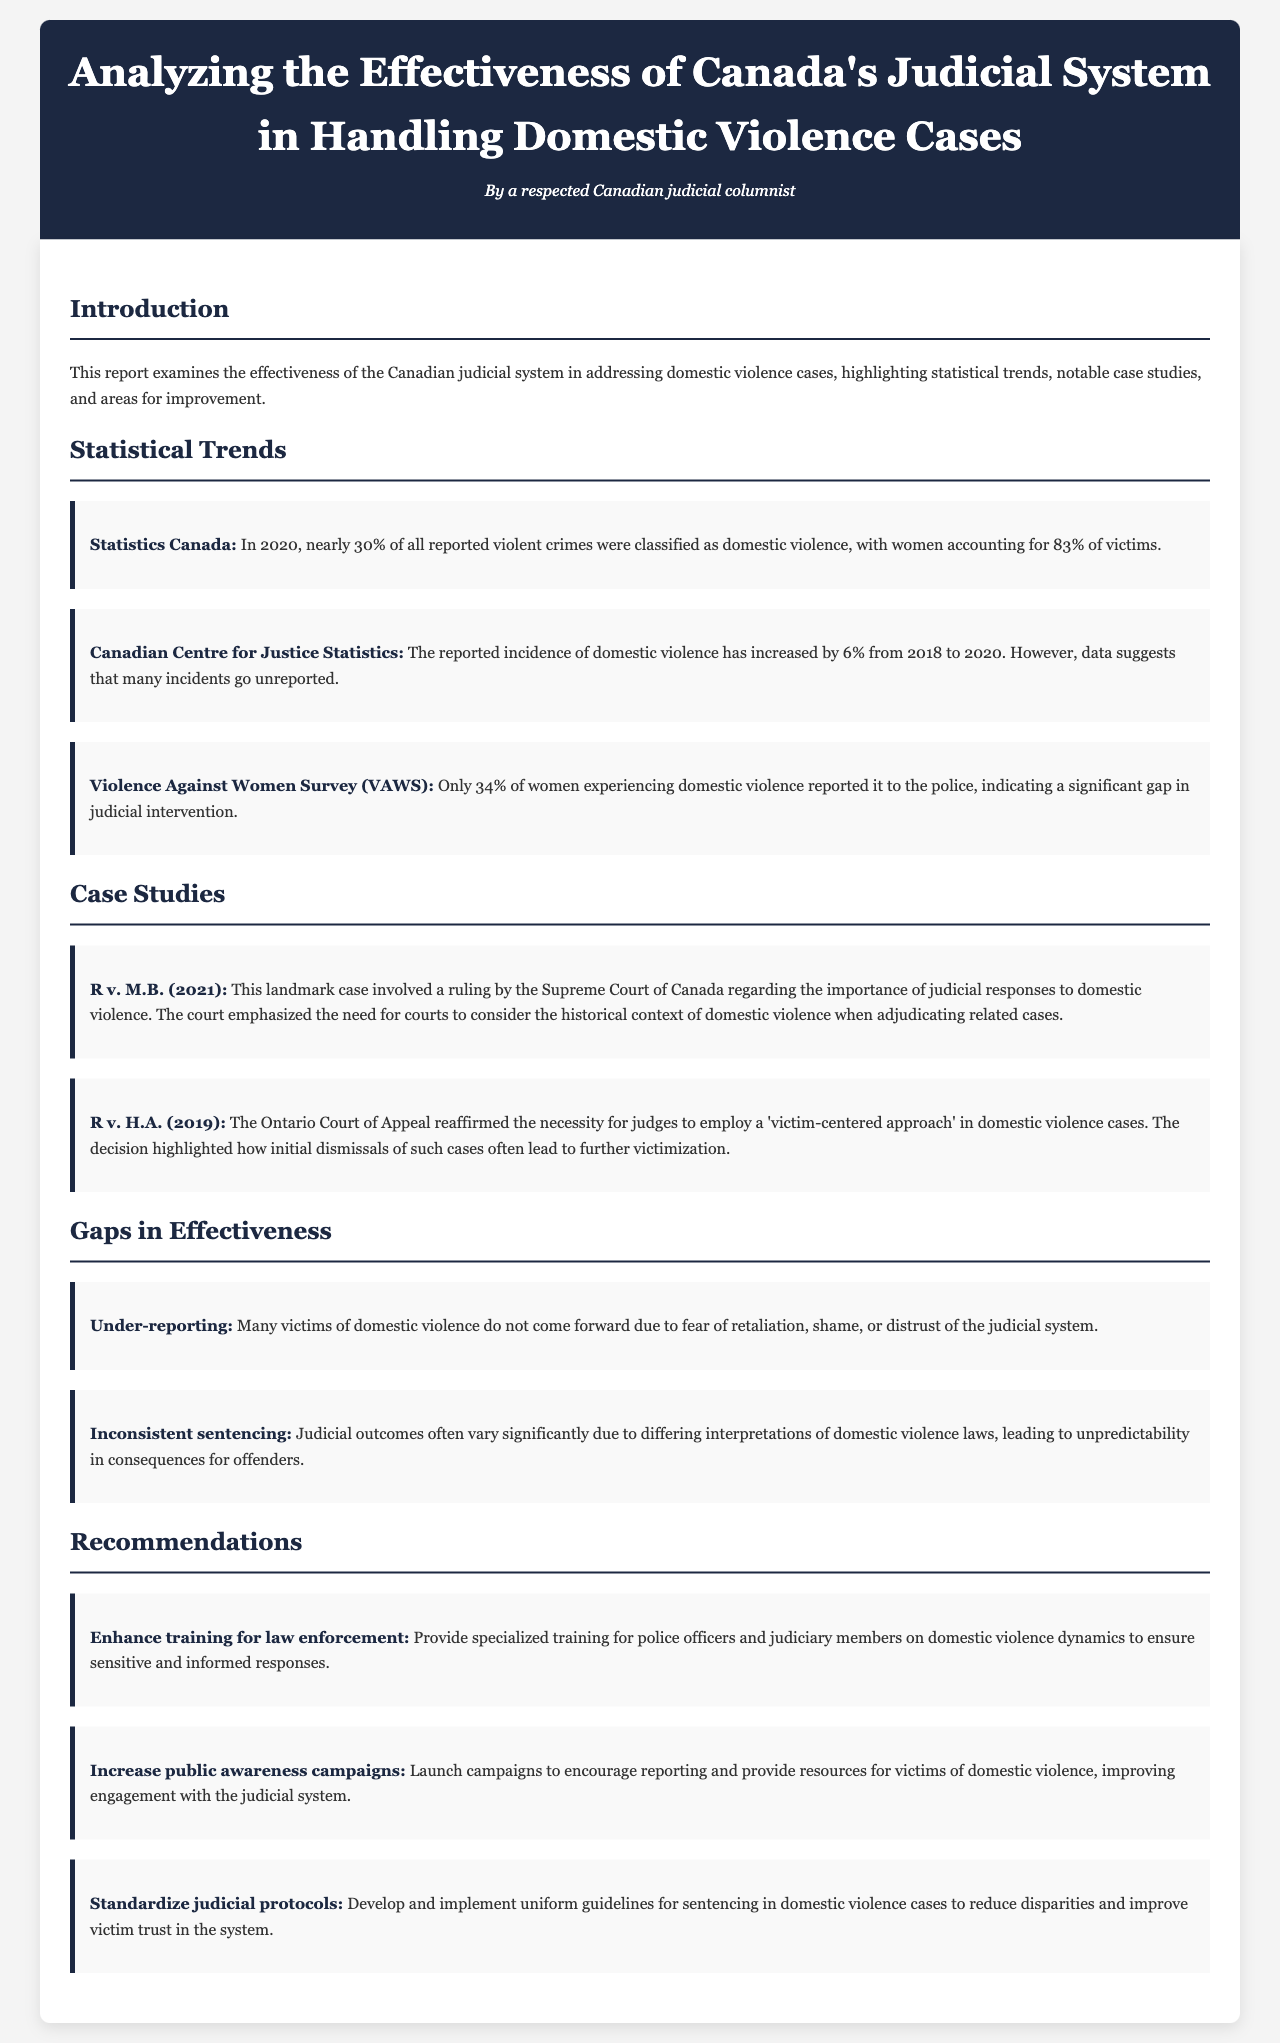What percentage of reported violent crimes were classified as domestic violence in 2020? The document states that nearly 30% of all reported violent crimes were classified as domestic violence in 2020.
Answer: 30% What is the reported increase in the incidence of domestic violence from 2018 to 2020? According to the document, the reported incidence of domestic violence increased by 6% from 2018 to 2020.
Answer: 6% What percentage of women experiencing domestic violence reported it to the police? The Violence Against Women Survey indicates that only 34% of women experiencing domestic violence reported it to the police.
Answer: 34% Which landmark case emphasized the historical context of domestic violence in judicial responses? The case R v. M.B. (2021) emphasized the importance of considering historical context in handling domestic violence cases.
Answer: R v. M.B. (2021) What is one main reason for under-reporting domestic violence? The document mentions fear of retaliation as one main reason why many victims do not come forward.
Answer: Fear of retaliation What was reaffirmed by the Ontario Court of Appeal in R v. H.A. (2019)? The Ontario Court of Appeal reaffirmed the necessity for judges to employ a 'victim-centered approach' in domestic violence cases.
Answer: Victim-centered approach What is one recommendation made for improving responses to domestic violence? One recommendation is to enhance training for law enforcement, providing specialized training on domestic violence dynamics.
Answer: Enhance training for law enforcement What is a significant gap identified in the effectiveness of Canada's judicial system regarding domestic violence? Inconsistent sentencing is identified as a significant gap in the effectiveness of the judicial system.
Answer: Inconsistent sentencing 